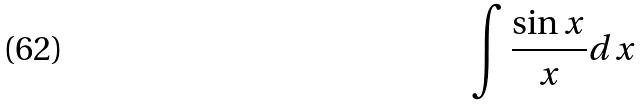<formula> <loc_0><loc_0><loc_500><loc_500>\int \frac { \sin x } { x } d x</formula> 